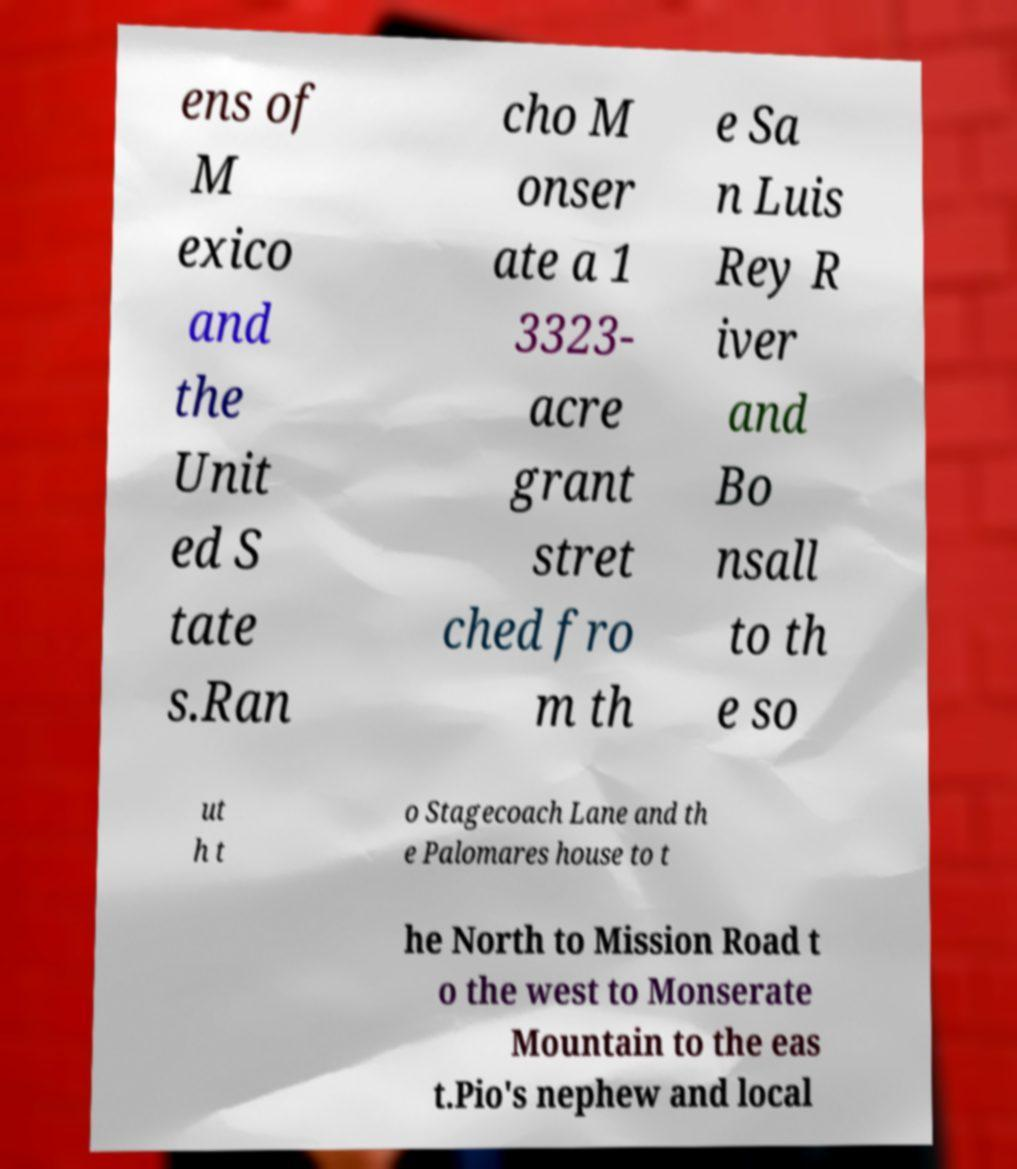I need the written content from this picture converted into text. Can you do that? ens of M exico and the Unit ed S tate s.Ran cho M onser ate a 1 3323- acre grant stret ched fro m th e Sa n Luis Rey R iver and Bo nsall to th e so ut h t o Stagecoach Lane and th e Palomares house to t he North to Mission Road t o the west to Monserate Mountain to the eas t.Pio's nephew and local 